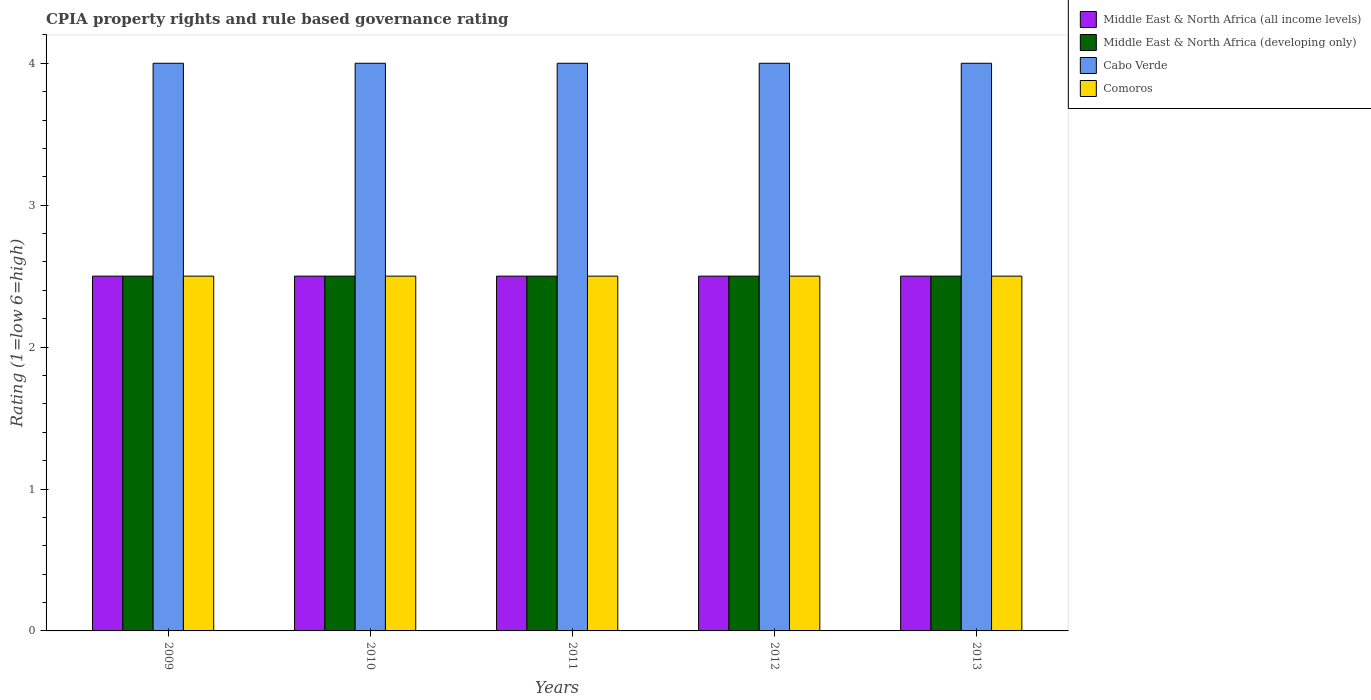How many different coloured bars are there?
Your answer should be compact. 4. Are the number of bars per tick equal to the number of legend labels?
Provide a succinct answer. Yes. How many bars are there on the 5th tick from the left?
Your answer should be very brief. 4. What is the label of the 2nd group of bars from the left?
Make the answer very short. 2010. In how many cases, is the number of bars for a given year not equal to the number of legend labels?
Your answer should be very brief. 0. What is the CPIA rating in Cabo Verde in 2009?
Give a very brief answer. 4. Across all years, what is the minimum CPIA rating in Cabo Verde?
Ensure brevity in your answer.  4. In which year was the CPIA rating in Comoros minimum?
Give a very brief answer. 2009. What is the total CPIA rating in Comoros in the graph?
Ensure brevity in your answer.  12.5. What is the ratio of the CPIA rating in Comoros in 2009 to that in 2011?
Your answer should be very brief. 1. Is the difference between the CPIA rating in Comoros in 2010 and 2011 greater than the difference between the CPIA rating in Middle East & North Africa (developing only) in 2010 and 2011?
Your answer should be compact. No. What is the difference between the highest and the lowest CPIA rating in Middle East & North Africa (developing only)?
Make the answer very short. 0. In how many years, is the CPIA rating in Middle East & North Africa (developing only) greater than the average CPIA rating in Middle East & North Africa (developing only) taken over all years?
Your answer should be very brief. 0. Is the sum of the CPIA rating in Cabo Verde in 2011 and 2013 greater than the maximum CPIA rating in Middle East & North Africa (all income levels) across all years?
Your answer should be compact. Yes. What does the 3rd bar from the left in 2012 represents?
Offer a very short reply. Cabo Verde. What does the 3rd bar from the right in 2010 represents?
Provide a succinct answer. Middle East & North Africa (developing only). Is it the case that in every year, the sum of the CPIA rating in Middle East & North Africa (developing only) and CPIA rating in Comoros is greater than the CPIA rating in Cabo Verde?
Keep it short and to the point. Yes. What is the difference between two consecutive major ticks on the Y-axis?
Your answer should be very brief. 1. How many legend labels are there?
Ensure brevity in your answer.  4. How are the legend labels stacked?
Offer a very short reply. Vertical. What is the title of the graph?
Make the answer very short. CPIA property rights and rule based governance rating. Does "Low income" appear as one of the legend labels in the graph?
Offer a very short reply. No. What is the label or title of the X-axis?
Provide a short and direct response. Years. What is the Rating (1=low 6=high) in Middle East & North Africa (all income levels) in 2009?
Offer a very short reply. 2.5. What is the Rating (1=low 6=high) in Cabo Verde in 2009?
Offer a very short reply. 4. What is the Rating (1=low 6=high) in Comoros in 2009?
Provide a short and direct response. 2.5. What is the Rating (1=low 6=high) of Middle East & North Africa (all income levels) in 2010?
Provide a succinct answer. 2.5. What is the Rating (1=low 6=high) of Middle East & North Africa (developing only) in 2010?
Offer a very short reply. 2.5. What is the Rating (1=low 6=high) of Cabo Verde in 2010?
Your response must be concise. 4. What is the Rating (1=low 6=high) of Comoros in 2010?
Your response must be concise. 2.5. What is the Rating (1=low 6=high) in Middle East & North Africa (all income levels) in 2011?
Give a very brief answer. 2.5. What is the Rating (1=low 6=high) in Cabo Verde in 2011?
Make the answer very short. 4. What is the Rating (1=low 6=high) of Comoros in 2011?
Your answer should be very brief. 2.5. What is the Rating (1=low 6=high) in Middle East & North Africa (all income levels) in 2012?
Provide a succinct answer. 2.5. What is the Rating (1=low 6=high) in Cabo Verde in 2012?
Offer a very short reply. 4. What is the Rating (1=low 6=high) of Comoros in 2012?
Ensure brevity in your answer.  2.5. What is the Rating (1=low 6=high) in Middle East & North Africa (developing only) in 2013?
Provide a succinct answer. 2.5. Across all years, what is the maximum Rating (1=low 6=high) of Middle East & North Africa (all income levels)?
Your answer should be compact. 2.5. Across all years, what is the maximum Rating (1=low 6=high) of Cabo Verde?
Keep it short and to the point. 4. Across all years, what is the minimum Rating (1=low 6=high) in Middle East & North Africa (all income levels)?
Give a very brief answer. 2.5. What is the difference between the Rating (1=low 6=high) in Cabo Verde in 2009 and that in 2010?
Provide a succinct answer. 0. What is the difference between the Rating (1=low 6=high) in Comoros in 2009 and that in 2010?
Give a very brief answer. 0. What is the difference between the Rating (1=low 6=high) in Middle East & North Africa (developing only) in 2009 and that in 2011?
Provide a succinct answer. 0. What is the difference between the Rating (1=low 6=high) in Middle East & North Africa (developing only) in 2009 and that in 2012?
Ensure brevity in your answer.  0. What is the difference between the Rating (1=low 6=high) in Cabo Verde in 2009 and that in 2012?
Your response must be concise. 0. What is the difference between the Rating (1=low 6=high) in Comoros in 2009 and that in 2012?
Your response must be concise. 0. What is the difference between the Rating (1=low 6=high) in Middle East & North Africa (developing only) in 2009 and that in 2013?
Provide a short and direct response. 0. What is the difference between the Rating (1=low 6=high) of Cabo Verde in 2009 and that in 2013?
Your response must be concise. 0. What is the difference between the Rating (1=low 6=high) of Middle East & North Africa (developing only) in 2010 and that in 2011?
Keep it short and to the point. 0. What is the difference between the Rating (1=low 6=high) of Comoros in 2010 and that in 2011?
Your answer should be very brief. 0. What is the difference between the Rating (1=low 6=high) of Middle East & North Africa (all income levels) in 2010 and that in 2012?
Ensure brevity in your answer.  0. What is the difference between the Rating (1=low 6=high) in Cabo Verde in 2010 and that in 2012?
Provide a succinct answer. 0. What is the difference between the Rating (1=low 6=high) in Middle East & North Africa (developing only) in 2010 and that in 2013?
Your response must be concise. 0. What is the difference between the Rating (1=low 6=high) of Comoros in 2010 and that in 2013?
Your answer should be compact. 0. What is the difference between the Rating (1=low 6=high) in Middle East & North Africa (all income levels) in 2011 and that in 2012?
Give a very brief answer. 0. What is the difference between the Rating (1=low 6=high) of Comoros in 2011 and that in 2012?
Provide a succinct answer. 0. What is the difference between the Rating (1=low 6=high) in Middle East & North Africa (developing only) in 2011 and that in 2013?
Offer a terse response. 0. What is the difference between the Rating (1=low 6=high) in Comoros in 2012 and that in 2013?
Ensure brevity in your answer.  0. What is the difference between the Rating (1=low 6=high) in Middle East & North Africa (all income levels) in 2009 and the Rating (1=low 6=high) in Middle East & North Africa (developing only) in 2010?
Give a very brief answer. 0. What is the difference between the Rating (1=low 6=high) of Middle East & North Africa (all income levels) in 2009 and the Rating (1=low 6=high) of Middle East & North Africa (developing only) in 2011?
Provide a short and direct response. 0. What is the difference between the Rating (1=low 6=high) in Middle East & North Africa (developing only) in 2009 and the Rating (1=low 6=high) in Cabo Verde in 2011?
Make the answer very short. -1.5. What is the difference between the Rating (1=low 6=high) of Middle East & North Africa (all income levels) in 2009 and the Rating (1=low 6=high) of Cabo Verde in 2012?
Make the answer very short. -1.5. What is the difference between the Rating (1=low 6=high) in Middle East & North Africa (all income levels) in 2009 and the Rating (1=low 6=high) in Middle East & North Africa (developing only) in 2013?
Provide a short and direct response. 0. What is the difference between the Rating (1=low 6=high) of Middle East & North Africa (all income levels) in 2009 and the Rating (1=low 6=high) of Cabo Verde in 2013?
Keep it short and to the point. -1.5. What is the difference between the Rating (1=low 6=high) in Middle East & North Africa (all income levels) in 2009 and the Rating (1=low 6=high) in Comoros in 2013?
Your response must be concise. 0. What is the difference between the Rating (1=low 6=high) of Cabo Verde in 2009 and the Rating (1=low 6=high) of Comoros in 2013?
Make the answer very short. 1.5. What is the difference between the Rating (1=low 6=high) in Middle East & North Africa (all income levels) in 2010 and the Rating (1=low 6=high) in Middle East & North Africa (developing only) in 2011?
Your answer should be compact. 0. What is the difference between the Rating (1=low 6=high) in Cabo Verde in 2010 and the Rating (1=low 6=high) in Comoros in 2011?
Give a very brief answer. 1.5. What is the difference between the Rating (1=low 6=high) of Middle East & North Africa (all income levels) in 2010 and the Rating (1=low 6=high) of Middle East & North Africa (developing only) in 2012?
Ensure brevity in your answer.  0. What is the difference between the Rating (1=low 6=high) in Middle East & North Africa (all income levels) in 2010 and the Rating (1=low 6=high) in Cabo Verde in 2012?
Your answer should be very brief. -1.5. What is the difference between the Rating (1=low 6=high) of Cabo Verde in 2010 and the Rating (1=low 6=high) of Comoros in 2012?
Offer a very short reply. 1.5. What is the difference between the Rating (1=low 6=high) of Middle East & North Africa (all income levels) in 2010 and the Rating (1=low 6=high) of Middle East & North Africa (developing only) in 2013?
Keep it short and to the point. 0. What is the difference between the Rating (1=low 6=high) of Middle East & North Africa (all income levels) in 2010 and the Rating (1=low 6=high) of Cabo Verde in 2013?
Provide a short and direct response. -1.5. What is the difference between the Rating (1=low 6=high) in Middle East & North Africa (developing only) in 2010 and the Rating (1=low 6=high) in Cabo Verde in 2013?
Your answer should be compact. -1.5. What is the difference between the Rating (1=low 6=high) of Middle East & North Africa (developing only) in 2010 and the Rating (1=low 6=high) of Comoros in 2013?
Provide a succinct answer. 0. What is the difference between the Rating (1=low 6=high) in Middle East & North Africa (all income levels) in 2011 and the Rating (1=low 6=high) in Middle East & North Africa (developing only) in 2012?
Offer a terse response. 0. What is the difference between the Rating (1=low 6=high) in Middle East & North Africa (all income levels) in 2011 and the Rating (1=low 6=high) in Cabo Verde in 2012?
Offer a very short reply. -1.5. What is the difference between the Rating (1=low 6=high) of Middle East & North Africa (all income levels) in 2011 and the Rating (1=low 6=high) of Comoros in 2012?
Provide a succinct answer. 0. What is the difference between the Rating (1=low 6=high) of Middle East & North Africa (all income levels) in 2011 and the Rating (1=low 6=high) of Middle East & North Africa (developing only) in 2013?
Offer a terse response. 0. What is the difference between the Rating (1=low 6=high) of Middle East & North Africa (all income levels) in 2011 and the Rating (1=low 6=high) of Comoros in 2013?
Offer a very short reply. 0. What is the difference between the Rating (1=low 6=high) in Middle East & North Africa (developing only) in 2011 and the Rating (1=low 6=high) in Cabo Verde in 2013?
Your answer should be compact. -1.5. What is the difference between the Rating (1=low 6=high) of Middle East & North Africa (all income levels) in 2012 and the Rating (1=low 6=high) of Cabo Verde in 2013?
Make the answer very short. -1.5. What is the difference between the Rating (1=low 6=high) of Middle East & North Africa (all income levels) in 2012 and the Rating (1=low 6=high) of Comoros in 2013?
Keep it short and to the point. 0. What is the average Rating (1=low 6=high) of Middle East & North Africa (all income levels) per year?
Make the answer very short. 2.5. What is the average Rating (1=low 6=high) in Middle East & North Africa (developing only) per year?
Offer a very short reply. 2.5. In the year 2009, what is the difference between the Rating (1=low 6=high) in Middle East & North Africa (all income levels) and Rating (1=low 6=high) in Cabo Verde?
Offer a very short reply. -1.5. In the year 2009, what is the difference between the Rating (1=low 6=high) in Middle East & North Africa (developing only) and Rating (1=low 6=high) in Cabo Verde?
Ensure brevity in your answer.  -1.5. In the year 2010, what is the difference between the Rating (1=low 6=high) in Cabo Verde and Rating (1=low 6=high) in Comoros?
Keep it short and to the point. 1.5. In the year 2011, what is the difference between the Rating (1=low 6=high) of Middle East & North Africa (all income levels) and Rating (1=low 6=high) of Middle East & North Africa (developing only)?
Ensure brevity in your answer.  0. In the year 2011, what is the difference between the Rating (1=low 6=high) in Middle East & North Africa (all income levels) and Rating (1=low 6=high) in Comoros?
Provide a succinct answer. 0. In the year 2011, what is the difference between the Rating (1=low 6=high) of Middle East & North Africa (developing only) and Rating (1=low 6=high) of Cabo Verde?
Ensure brevity in your answer.  -1.5. In the year 2011, what is the difference between the Rating (1=low 6=high) in Middle East & North Africa (developing only) and Rating (1=low 6=high) in Comoros?
Your answer should be compact. 0. In the year 2011, what is the difference between the Rating (1=low 6=high) in Cabo Verde and Rating (1=low 6=high) in Comoros?
Your answer should be very brief. 1.5. In the year 2012, what is the difference between the Rating (1=low 6=high) in Middle East & North Africa (all income levels) and Rating (1=low 6=high) in Cabo Verde?
Make the answer very short. -1.5. In the year 2012, what is the difference between the Rating (1=low 6=high) of Middle East & North Africa (all income levels) and Rating (1=low 6=high) of Comoros?
Your answer should be very brief. 0. In the year 2012, what is the difference between the Rating (1=low 6=high) in Middle East & North Africa (developing only) and Rating (1=low 6=high) in Cabo Verde?
Keep it short and to the point. -1.5. In the year 2013, what is the difference between the Rating (1=low 6=high) in Middle East & North Africa (all income levels) and Rating (1=low 6=high) in Comoros?
Your response must be concise. 0. What is the ratio of the Rating (1=low 6=high) of Middle East & North Africa (developing only) in 2009 to that in 2010?
Provide a succinct answer. 1. What is the ratio of the Rating (1=low 6=high) in Cabo Verde in 2009 to that in 2010?
Ensure brevity in your answer.  1. What is the ratio of the Rating (1=low 6=high) of Comoros in 2009 to that in 2010?
Your answer should be compact. 1. What is the ratio of the Rating (1=low 6=high) in Middle East & North Africa (all income levels) in 2009 to that in 2011?
Your answer should be compact. 1. What is the ratio of the Rating (1=low 6=high) of Middle East & North Africa (developing only) in 2009 to that in 2012?
Provide a short and direct response. 1. What is the ratio of the Rating (1=low 6=high) of Cabo Verde in 2009 to that in 2012?
Make the answer very short. 1. What is the ratio of the Rating (1=low 6=high) in Comoros in 2009 to that in 2012?
Ensure brevity in your answer.  1. What is the ratio of the Rating (1=low 6=high) of Cabo Verde in 2009 to that in 2013?
Your response must be concise. 1. What is the ratio of the Rating (1=low 6=high) in Middle East & North Africa (all income levels) in 2010 to that in 2011?
Provide a succinct answer. 1. What is the ratio of the Rating (1=low 6=high) in Middle East & North Africa (all income levels) in 2010 to that in 2012?
Your response must be concise. 1. What is the ratio of the Rating (1=low 6=high) in Middle East & North Africa (developing only) in 2010 to that in 2012?
Your answer should be very brief. 1. What is the ratio of the Rating (1=low 6=high) of Cabo Verde in 2010 to that in 2012?
Make the answer very short. 1. What is the ratio of the Rating (1=low 6=high) in Middle East & North Africa (developing only) in 2011 to that in 2012?
Ensure brevity in your answer.  1. What is the ratio of the Rating (1=low 6=high) of Cabo Verde in 2011 to that in 2012?
Ensure brevity in your answer.  1. What is the ratio of the Rating (1=low 6=high) in Middle East & North Africa (all income levels) in 2011 to that in 2013?
Your answer should be compact. 1. What is the ratio of the Rating (1=low 6=high) of Middle East & North Africa (all income levels) in 2012 to that in 2013?
Make the answer very short. 1. What is the ratio of the Rating (1=low 6=high) in Middle East & North Africa (developing only) in 2012 to that in 2013?
Your answer should be very brief. 1. What is the ratio of the Rating (1=low 6=high) in Cabo Verde in 2012 to that in 2013?
Provide a short and direct response. 1. What is the difference between the highest and the second highest Rating (1=low 6=high) of Middle East & North Africa (all income levels)?
Provide a short and direct response. 0. What is the difference between the highest and the second highest Rating (1=low 6=high) of Middle East & North Africa (developing only)?
Your answer should be very brief. 0. What is the difference between the highest and the lowest Rating (1=low 6=high) in Middle East & North Africa (all income levels)?
Your response must be concise. 0. What is the difference between the highest and the lowest Rating (1=low 6=high) of Middle East & North Africa (developing only)?
Make the answer very short. 0. What is the difference between the highest and the lowest Rating (1=low 6=high) in Cabo Verde?
Give a very brief answer. 0. What is the difference between the highest and the lowest Rating (1=low 6=high) of Comoros?
Provide a succinct answer. 0. 